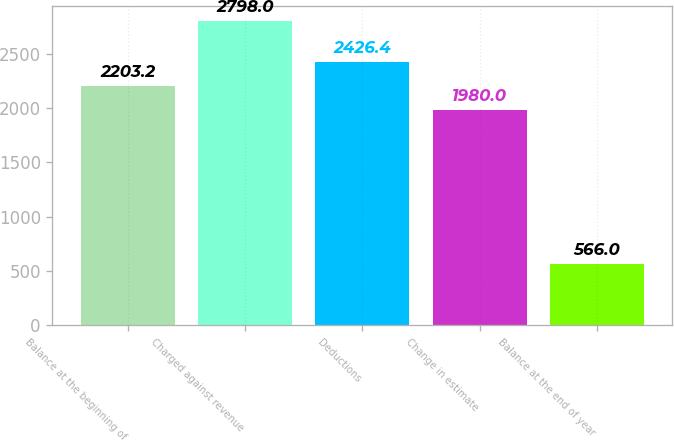Convert chart to OTSL. <chart><loc_0><loc_0><loc_500><loc_500><bar_chart><fcel>Balance at the beginning of<fcel>Charged against revenue<fcel>Deductions<fcel>Change in estimate<fcel>Balance at the end of year<nl><fcel>2203.2<fcel>2798<fcel>2426.4<fcel>1980<fcel>566<nl></chart> 